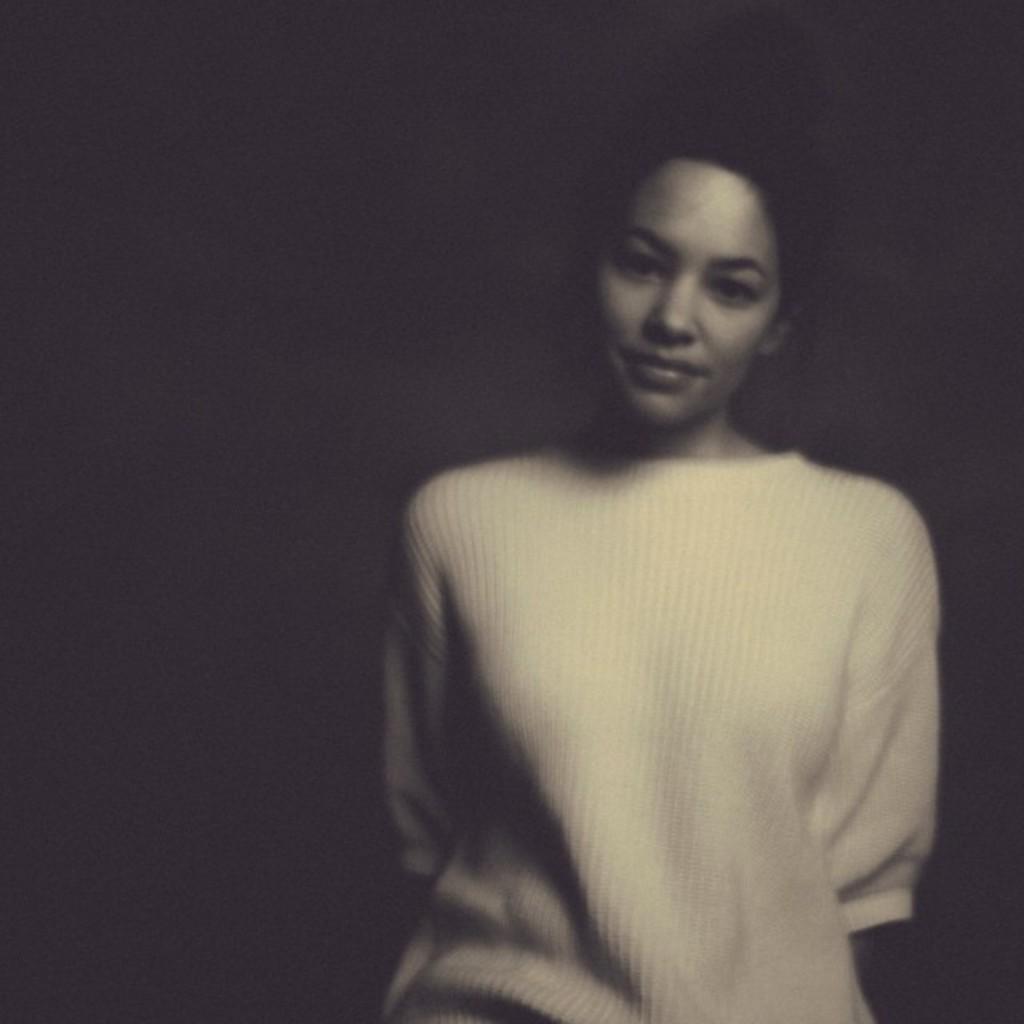In one or two sentences, can you explain what this image depicts? In this image there is a woman standing. 